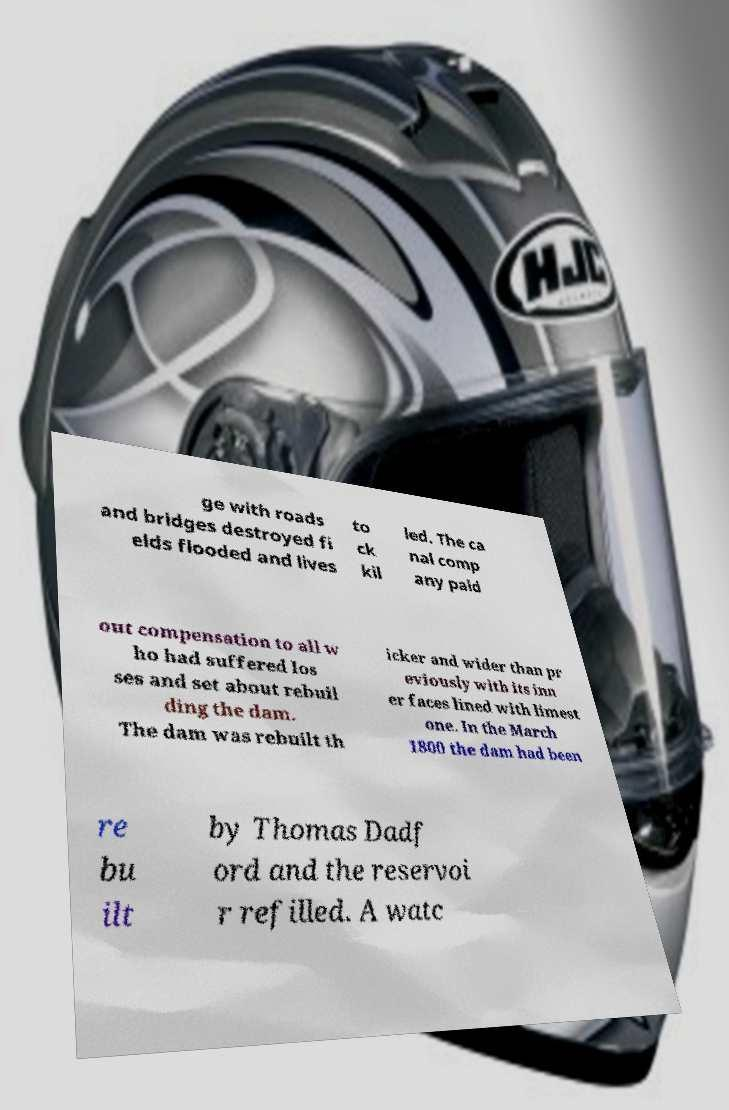Could you extract and type out the text from this image? ge with roads and bridges destroyed fi elds flooded and lives to ck kil led. The ca nal comp any paid out compensation to all w ho had suffered los ses and set about rebuil ding the dam. The dam was rebuilt th icker and wider than pr eviously with its inn er faces lined with limest one. In the March 1800 the dam had been re bu ilt by Thomas Dadf ord and the reservoi r refilled. A watc 